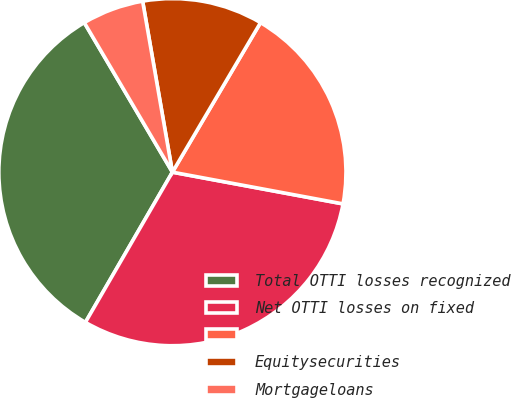Convert chart to OTSL. <chart><loc_0><loc_0><loc_500><loc_500><pie_chart><fcel>Total OTTI losses recognized<fcel>Net OTTI losses on fixed<fcel>Unnamed: 2<fcel>Equitysecurities<fcel>Mortgageloans<nl><fcel>33.17%<fcel>30.43%<fcel>19.45%<fcel>11.22%<fcel>5.73%<nl></chart> 